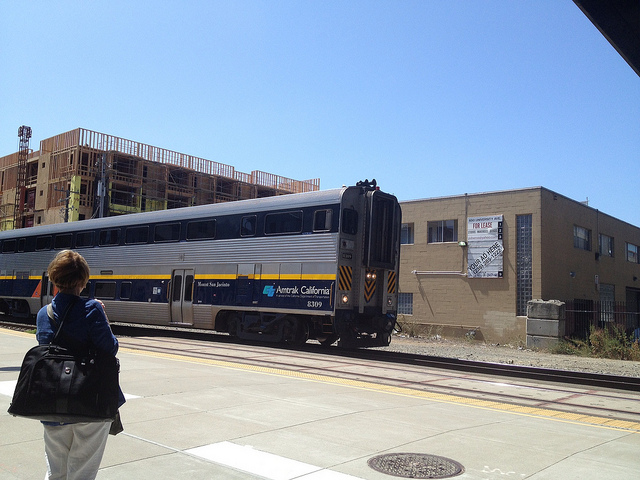Identify the text displayed in this image. Amozk California FOR LEASE 